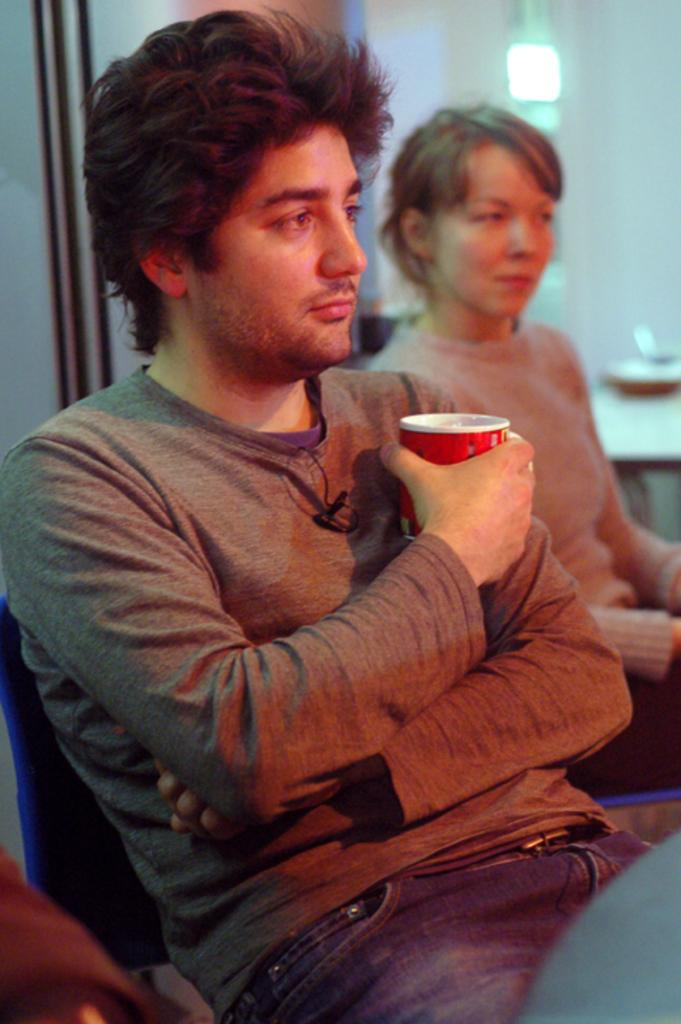How many people are present in the image? There are two persons sitting in the image. What is one person holding in the image? One person is holding a cup. What can be seen in the background of the image? There is a wall in the background of the image. What type of dog can be seen playing with a wine bottle in the image? There is no dog or wine bottle present in the image. 